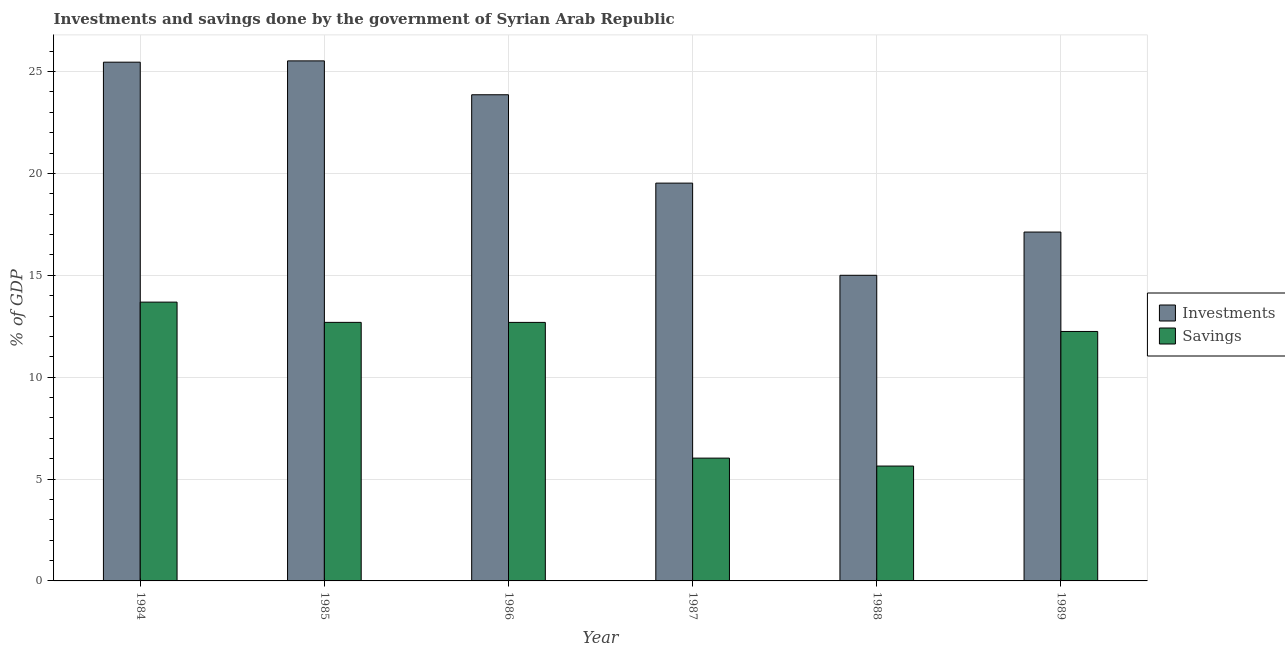Are the number of bars per tick equal to the number of legend labels?
Provide a succinct answer. Yes. Are the number of bars on each tick of the X-axis equal?
Your answer should be very brief. Yes. How many bars are there on the 6th tick from the left?
Your response must be concise. 2. In how many cases, is the number of bars for a given year not equal to the number of legend labels?
Your answer should be compact. 0. What is the investments of government in 1987?
Offer a very short reply. 19.52. Across all years, what is the maximum savings of government?
Provide a succinct answer. 13.68. Across all years, what is the minimum savings of government?
Offer a terse response. 5.64. In which year was the investments of government minimum?
Keep it short and to the point. 1988. What is the total savings of government in the graph?
Your response must be concise. 62.96. What is the difference between the investments of government in 1988 and that in 1989?
Give a very brief answer. -2.12. What is the difference between the investments of government in 1988 and the savings of government in 1986?
Provide a short and direct response. -8.86. What is the average investments of government per year?
Provide a succinct answer. 21.08. In the year 1985, what is the difference between the savings of government and investments of government?
Provide a short and direct response. 0. What is the ratio of the investments of government in 1986 to that in 1987?
Ensure brevity in your answer.  1.22. Is the difference between the savings of government in 1987 and 1989 greater than the difference between the investments of government in 1987 and 1989?
Your answer should be very brief. No. What is the difference between the highest and the second highest investments of government?
Make the answer very short. 0.06. What is the difference between the highest and the lowest savings of government?
Offer a terse response. 8.05. Is the sum of the investments of government in 1987 and 1989 greater than the maximum savings of government across all years?
Provide a short and direct response. Yes. What does the 2nd bar from the left in 1988 represents?
Give a very brief answer. Savings. What does the 1st bar from the right in 1986 represents?
Give a very brief answer. Savings. How many years are there in the graph?
Keep it short and to the point. 6. Are the values on the major ticks of Y-axis written in scientific E-notation?
Your answer should be compact. No. Does the graph contain any zero values?
Offer a very short reply. No. Does the graph contain grids?
Offer a terse response. Yes. How are the legend labels stacked?
Your response must be concise. Vertical. What is the title of the graph?
Provide a succinct answer. Investments and savings done by the government of Syrian Arab Republic. Does "UN agencies" appear as one of the legend labels in the graph?
Keep it short and to the point. No. What is the label or title of the Y-axis?
Give a very brief answer. % of GDP. What is the % of GDP in Investments in 1984?
Ensure brevity in your answer.  25.46. What is the % of GDP in Savings in 1984?
Keep it short and to the point. 13.68. What is the % of GDP in Investments in 1985?
Your answer should be compact. 25.52. What is the % of GDP of Savings in 1985?
Provide a succinct answer. 12.69. What is the % of GDP in Investments in 1986?
Ensure brevity in your answer.  23.86. What is the % of GDP of Savings in 1986?
Give a very brief answer. 12.69. What is the % of GDP in Investments in 1987?
Your answer should be very brief. 19.52. What is the % of GDP in Savings in 1987?
Provide a short and direct response. 6.03. What is the % of GDP of Investments in 1988?
Your answer should be very brief. 15. What is the % of GDP in Savings in 1988?
Offer a terse response. 5.64. What is the % of GDP of Investments in 1989?
Ensure brevity in your answer.  17.12. What is the % of GDP in Savings in 1989?
Your response must be concise. 12.24. Across all years, what is the maximum % of GDP in Investments?
Your response must be concise. 25.52. Across all years, what is the maximum % of GDP in Savings?
Provide a succinct answer. 13.68. Across all years, what is the minimum % of GDP of Investments?
Offer a very short reply. 15. Across all years, what is the minimum % of GDP of Savings?
Your response must be concise. 5.64. What is the total % of GDP in Investments in the graph?
Your response must be concise. 126.48. What is the total % of GDP of Savings in the graph?
Your answer should be compact. 62.97. What is the difference between the % of GDP of Investments in 1984 and that in 1985?
Keep it short and to the point. -0.06. What is the difference between the % of GDP in Investments in 1984 and that in 1986?
Keep it short and to the point. 1.6. What is the difference between the % of GDP of Savings in 1984 and that in 1986?
Make the answer very short. 1. What is the difference between the % of GDP of Investments in 1984 and that in 1987?
Provide a short and direct response. 5.93. What is the difference between the % of GDP of Savings in 1984 and that in 1987?
Your response must be concise. 7.66. What is the difference between the % of GDP of Investments in 1984 and that in 1988?
Make the answer very short. 10.46. What is the difference between the % of GDP in Savings in 1984 and that in 1988?
Your answer should be very brief. 8.05. What is the difference between the % of GDP in Investments in 1984 and that in 1989?
Your answer should be compact. 8.34. What is the difference between the % of GDP of Savings in 1984 and that in 1989?
Offer a very short reply. 1.44. What is the difference between the % of GDP in Investments in 1985 and that in 1986?
Your answer should be compact. 1.66. What is the difference between the % of GDP of Savings in 1985 and that in 1986?
Give a very brief answer. 0. What is the difference between the % of GDP in Investments in 1985 and that in 1987?
Offer a very short reply. 6. What is the difference between the % of GDP in Savings in 1985 and that in 1987?
Provide a succinct answer. 6.66. What is the difference between the % of GDP in Investments in 1985 and that in 1988?
Provide a succinct answer. 10.52. What is the difference between the % of GDP in Savings in 1985 and that in 1988?
Give a very brief answer. 7.05. What is the difference between the % of GDP in Investments in 1985 and that in 1989?
Your answer should be very brief. 8.4. What is the difference between the % of GDP of Savings in 1985 and that in 1989?
Keep it short and to the point. 0.45. What is the difference between the % of GDP of Investments in 1986 and that in 1987?
Your response must be concise. 4.34. What is the difference between the % of GDP in Savings in 1986 and that in 1987?
Keep it short and to the point. 6.66. What is the difference between the % of GDP in Investments in 1986 and that in 1988?
Provide a succinct answer. 8.86. What is the difference between the % of GDP of Savings in 1986 and that in 1988?
Offer a terse response. 7.05. What is the difference between the % of GDP in Investments in 1986 and that in 1989?
Make the answer very short. 6.74. What is the difference between the % of GDP of Savings in 1986 and that in 1989?
Your answer should be compact. 0.45. What is the difference between the % of GDP in Investments in 1987 and that in 1988?
Make the answer very short. 4.52. What is the difference between the % of GDP of Savings in 1987 and that in 1988?
Give a very brief answer. 0.39. What is the difference between the % of GDP of Investments in 1987 and that in 1989?
Make the answer very short. 2.4. What is the difference between the % of GDP in Savings in 1987 and that in 1989?
Your response must be concise. -6.22. What is the difference between the % of GDP of Investments in 1988 and that in 1989?
Offer a very short reply. -2.12. What is the difference between the % of GDP in Savings in 1988 and that in 1989?
Make the answer very short. -6.61. What is the difference between the % of GDP of Investments in 1984 and the % of GDP of Savings in 1985?
Keep it short and to the point. 12.77. What is the difference between the % of GDP in Investments in 1984 and the % of GDP in Savings in 1986?
Keep it short and to the point. 12.77. What is the difference between the % of GDP of Investments in 1984 and the % of GDP of Savings in 1987?
Your answer should be compact. 19.43. What is the difference between the % of GDP of Investments in 1984 and the % of GDP of Savings in 1988?
Provide a succinct answer. 19.82. What is the difference between the % of GDP of Investments in 1984 and the % of GDP of Savings in 1989?
Offer a very short reply. 13.22. What is the difference between the % of GDP in Investments in 1985 and the % of GDP in Savings in 1986?
Ensure brevity in your answer.  12.83. What is the difference between the % of GDP in Investments in 1985 and the % of GDP in Savings in 1987?
Your response must be concise. 19.5. What is the difference between the % of GDP in Investments in 1985 and the % of GDP in Savings in 1988?
Provide a short and direct response. 19.88. What is the difference between the % of GDP of Investments in 1985 and the % of GDP of Savings in 1989?
Your response must be concise. 13.28. What is the difference between the % of GDP in Investments in 1986 and the % of GDP in Savings in 1987?
Keep it short and to the point. 17.83. What is the difference between the % of GDP of Investments in 1986 and the % of GDP of Savings in 1988?
Provide a short and direct response. 18.22. What is the difference between the % of GDP in Investments in 1986 and the % of GDP in Savings in 1989?
Make the answer very short. 11.62. What is the difference between the % of GDP of Investments in 1987 and the % of GDP of Savings in 1988?
Your answer should be very brief. 13.89. What is the difference between the % of GDP in Investments in 1987 and the % of GDP in Savings in 1989?
Offer a terse response. 7.28. What is the difference between the % of GDP of Investments in 1988 and the % of GDP of Savings in 1989?
Keep it short and to the point. 2.76. What is the average % of GDP of Investments per year?
Offer a very short reply. 21.08. What is the average % of GDP of Savings per year?
Keep it short and to the point. 10.49. In the year 1984, what is the difference between the % of GDP in Investments and % of GDP in Savings?
Provide a short and direct response. 11.77. In the year 1985, what is the difference between the % of GDP in Investments and % of GDP in Savings?
Give a very brief answer. 12.83. In the year 1986, what is the difference between the % of GDP of Investments and % of GDP of Savings?
Ensure brevity in your answer.  11.17. In the year 1987, what is the difference between the % of GDP in Investments and % of GDP in Savings?
Your answer should be very brief. 13.5. In the year 1988, what is the difference between the % of GDP in Investments and % of GDP in Savings?
Give a very brief answer. 9.36. In the year 1989, what is the difference between the % of GDP of Investments and % of GDP of Savings?
Your answer should be very brief. 4.88. What is the ratio of the % of GDP of Savings in 1984 to that in 1985?
Ensure brevity in your answer.  1.08. What is the ratio of the % of GDP of Investments in 1984 to that in 1986?
Offer a terse response. 1.07. What is the ratio of the % of GDP in Savings in 1984 to that in 1986?
Offer a terse response. 1.08. What is the ratio of the % of GDP in Investments in 1984 to that in 1987?
Make the answer very short. 1.3. What is the ratio of the % of GDP of Savings in 1984 to that in 1987?
Give a very brief answer. 2.27. What is the ratio of the % of GDP of Investments in 1984 to that in 1988?
Make the answer very short. 1.7. What is the ratio of the % of GDP in Savings in 1984 to that in 1988?
Your answer should be compact. 2.43. What is the ratio of the % of GDP of Investments in 1984 to that in 1989?
Provide a succinct answer. 1.49. What is the ratio of the % of GDP of Savings in 1984 to that in 1989?
Provide a short and direct response. 1.12. What is the ratio of the % of GDP of Investments in 1985 to that in 1986?
Your answer should be compact. 1.07. What is the ratio of the % of GDP of Savings in 1985 to that in 1986?
Provide a short and direct response. 1. What is the ratio of the % of GDP of Investments in 1985 to that in 1987?
Your response must be concise. 1.31. What is the ratio of the % of GDP of Savings in 1985 to that in 1987?
Keep it short and to the point. 2.11. What is the ratio of the % of GDP of Investments in 1985 to that in 1988?
Provide a short and direct response. 1.7. What is the ratio of the % of GDP in Savings in 1985 to that in 1988?
Your answer should be very brief. 2.25. What is the ratio of the % of GDP in Investments in 1985 to that in 1989?
Provide a short and direct response. 1.49. What is the ratio of the % of GDP of Savings in 1985 to that in 1989?
Provide a short and direct response. 1.04. What is the ratio of the % of GDP of Investments in 1986 to that in 1987?
Offer a very short reply. 1.22. What is the ratio of the % of GDP in Savings in 1986 to that in 1987?
Make the answer very short. 2.11. What is the ratio of the % of GDP of Investments in 1986 to that in 1988?
Ensure brevity in your answer.  1.59. What is the ratio of the % of GDP of Savings in 1986 to that in 1988?
Provide a short and direct response. 2.25. What is the ratio of the % of GDP of Investments in 1986 to that in 1989?
Ensure brevity in your answer.  1.39. What is the ratio of the % of GDP in Savings in 1986 to that in 1989?
Your answer should be compact. 1.04. What is the ratio of the % of GDP in Investments in 1987 to that in 1988?
Provide a short and direct response. 1.3. What is the ratio of the % of GDP of Savings in 1987 to that in 1988?
Offer a terse response. 1.07. What is the ratio of the % of GDP in Investments in 1987 to that in 1989?
Your answer should be compact. 1.14. What is the ratio of the % of GDP in Savings in 1987 to that in 1989?
Provide a succinct answer. 0.49. What is the ratio of the % of GDP in Investments in 1988 to that in 1989?
Your response must be concise. 0.88. What is the ratio of the % of GDP of Savings in 1988 to that in 1989?
Keep it short and to the point. 0.46. What is the difference between the highest and the second highest % of GDP in Investments?
Offer a very short reply. 0.06. What is the difference between the highest and the second highest % of GDP of Savings?
Offer a very short reply. 0.99. What is the difference between the highest and the lowest % of GDP in Investments?
Your answer should be compact. 10.52. What is the difference between the highest and the lowest % of GDP in Savings?
Keep it short and to the point. 8.05. 